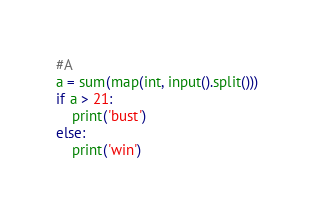Convert code to text. <code><loc_0><loc_0><loc_500><loc_500><_Python_>#A
a = sum(map(int, input().split()))
if a > 21:
    print('bust')
else:
    print('win')</code> 